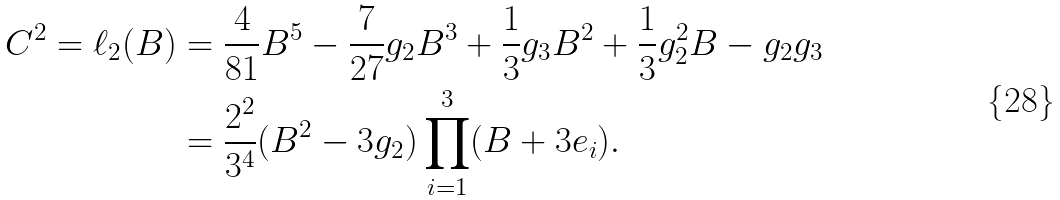Convert formula to latex. <formula><loc_0><loc_0><loc_500><loc_500>C ^ { 2 } = \ell _ { 2 } ( B ) & = \frac { 4 } { 8 1 } B ^ { 5 } - \frac { 7 } { 2 7 } g _ { 2 } B ^ { 3 } + \frac { 1 } { 3 } g _ { 3 } B ^ { 2 } + \frac { 1 } { 3 } g _ { 2 } ^ { 2 } B - g _ { 2 } g _ { 3 } \\ & = \frac { 2 ^ { 2 } } { 3 ^ { 4 } } ( B ^ { 2 } - 3 g _ { 2 } ) \prod _ { i = 1 } ^ { 3 } ( B + 3 e _ { i } ) .</formula> 